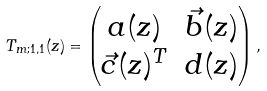<formula> <loc_0><loc_0><loc_500><loc_500>T _ { m ; 1 , 1 } ( z ) = \begin{pmatrix} a ( z ) & \vec { b } ( z ) \\ \vec { c } ( z ) ^ { T } & d ( z ) \end{pmatrix} ,</formula> 